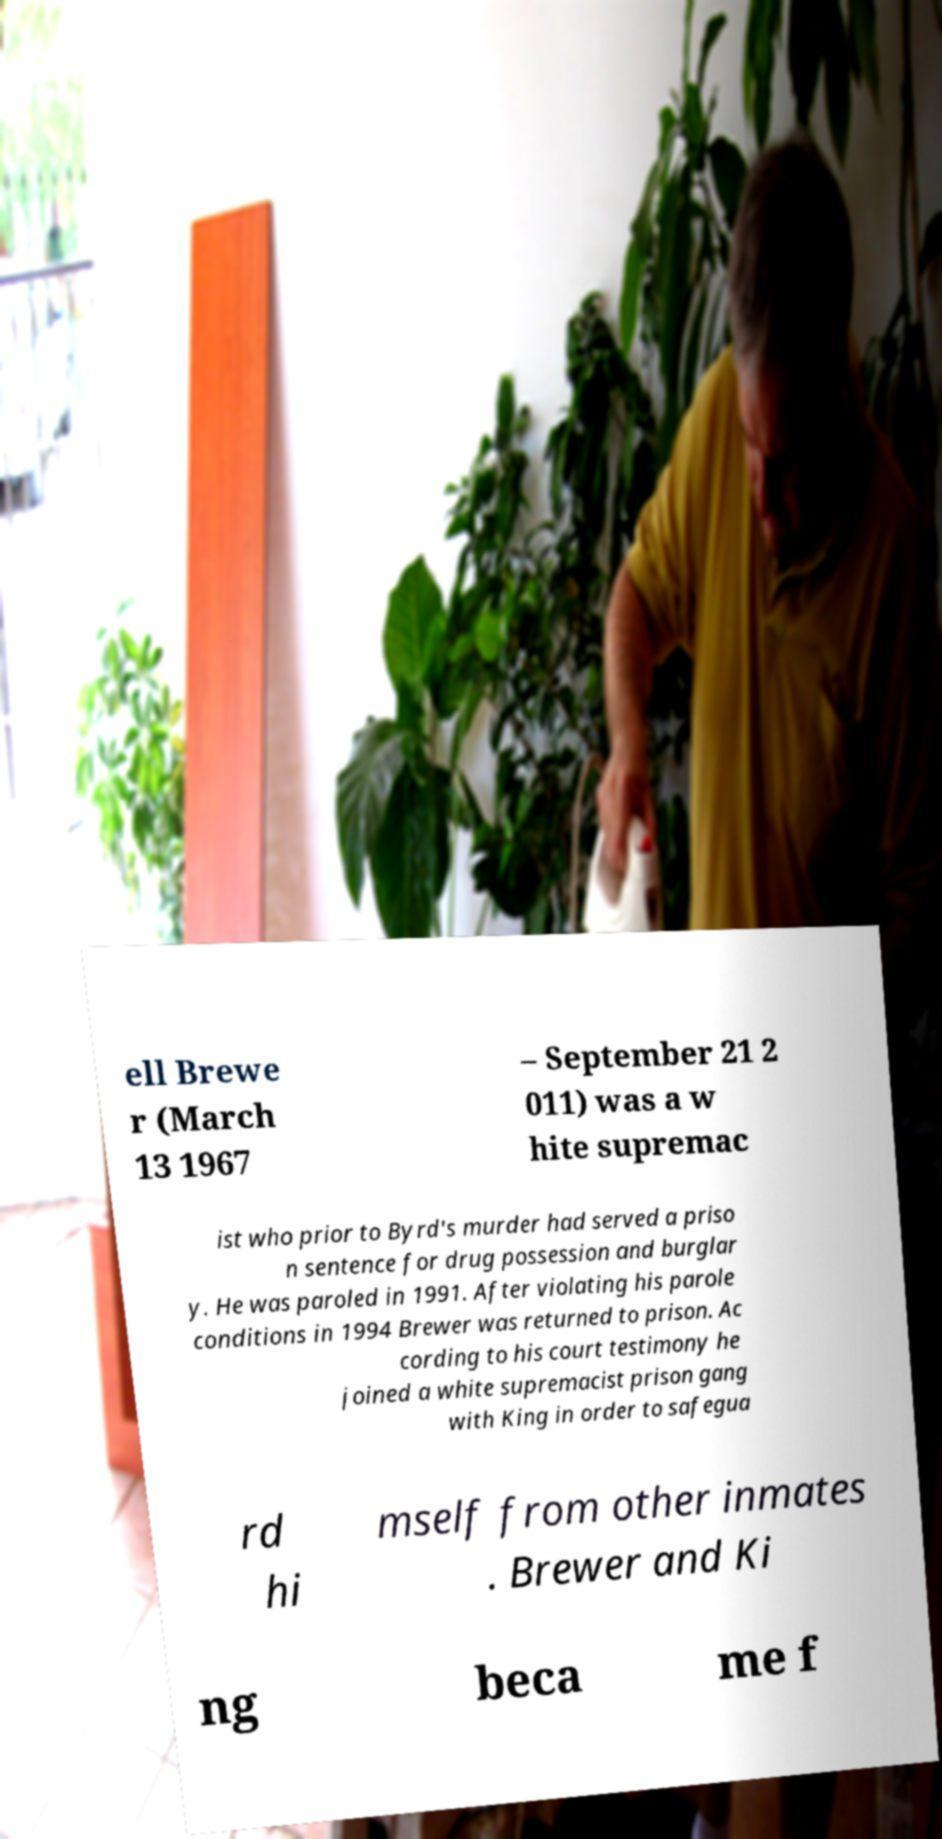Can you accurately transcribe the text from the provided image for me? ell Brewe r (March 13 1967 – September 21 2 011) was a w hite supremac ist who prior to Byrd's murder had served a priso n sentence for drug possession and burglar y. He was paroled in 1991. After violating his parole conditions in 1994 Brewer was returned to prison. Ac cording to his court testimony he joined a white supremacist prison gang with King in order to safegua rd hi mself from other inmates . Brewer and Ki ng beca me f 